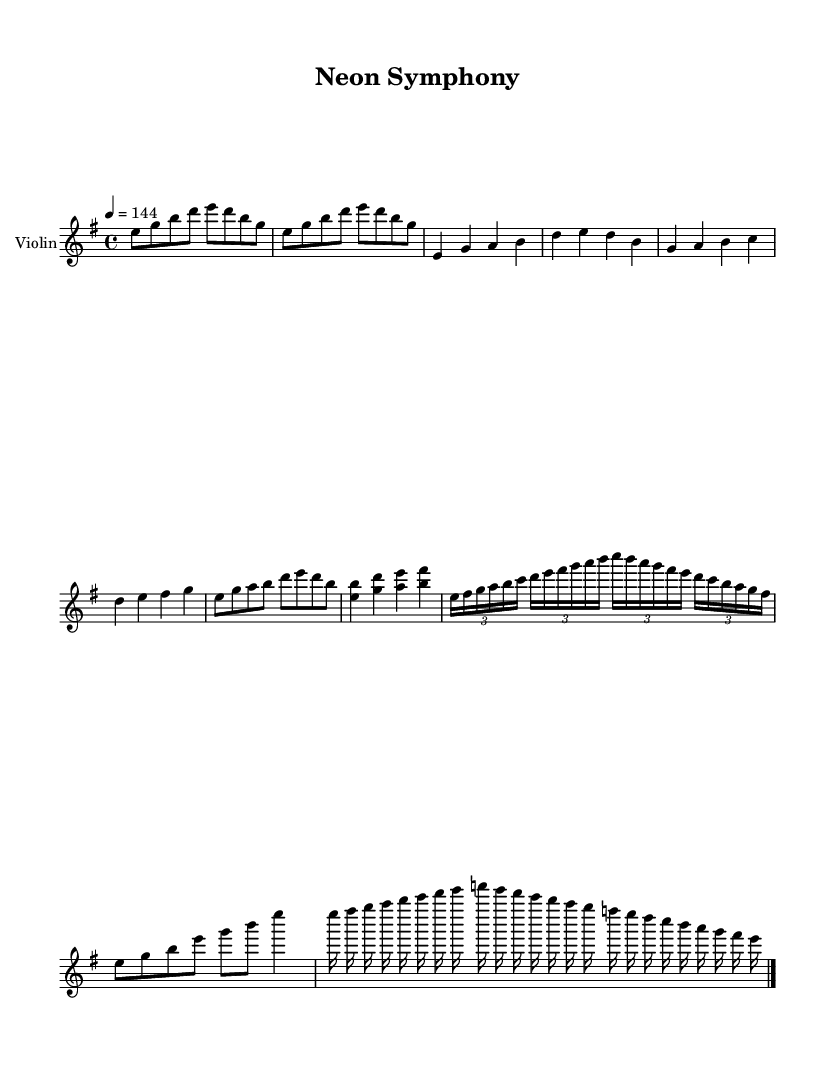What is the key signature of this music? The key signature is indicated at the beginning of the score, and it shows one sharp, which corresponds to E minor.
Answer: E minor What is the time signature of this music? The time signature is located at the beginning, indicating that there are four beats per measure, which is represented as 4/4.
Answer: 4/4 What is the tempo marking for the piece? The tempo is specified at the beginning of the piece, indicating a speed of 144 beats per minute, which is notated as "4 = 144".
Answer: 144 How many measures are in the instrumental break? Counting from the section labeled "Instrumental Break," there are a total of two measures visible in that part, as indicated by the structure of the music.
Answer: 2 What type of instrumental section appears after the chorus? Following the chorus, there is a section labeled "Instrumental Break (Neoclassical)," which suggests that neoclassical elements are incorporated into this part.
Answer: Neoclassical What technique is used in the bridge labeled for the violin? The section labeled “Bridge (Violin Cadenza)” indicates that the violin plays a cadenza, which is a free solo passage with embellishments.
Answer: Cadenza What is the highest pitch in the score? Observing the score, the highest pitch is found in the instrumental break where the note "g" occurs in a higher octave than the others, marking the peak of the melodic line.
Answer: g 